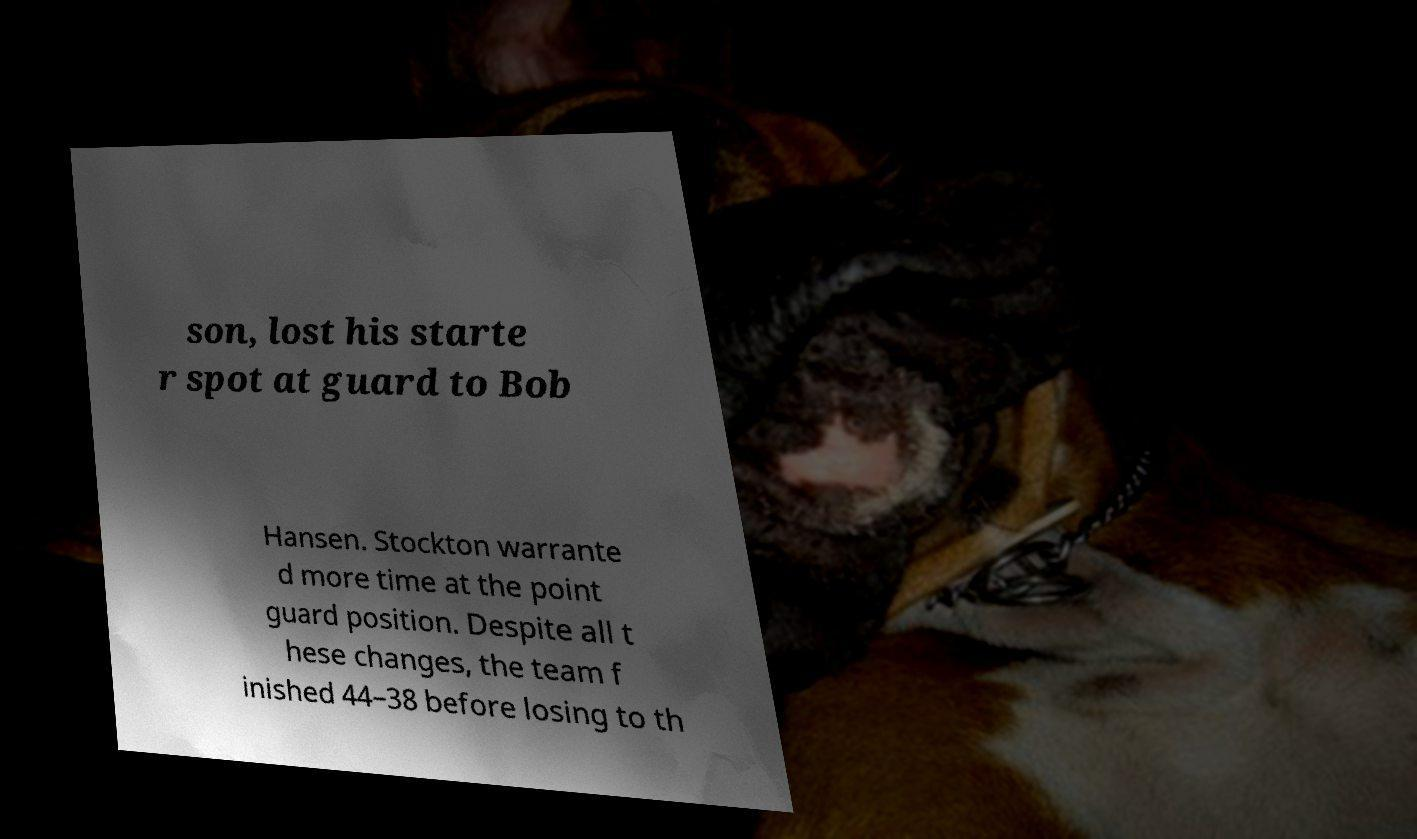What messages or text are displayed in this image? I need them in a readable, typed format. son, lost his starte r spot at guard to Bob Hansen. Stockton warrante d more time at the point guard position. Despite all t hese changes, the team f inished 44–38 before losing to th 